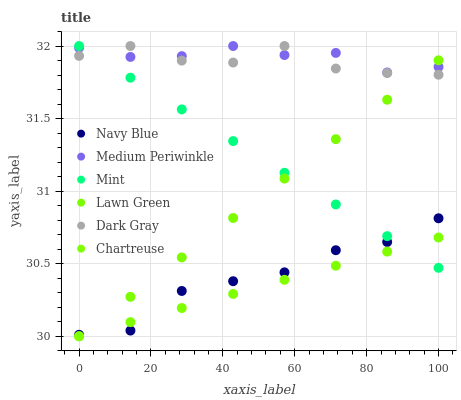Does Chartreuse have the minimum area under the curve?
Answer yes or no. Yes. Does Medium Periwinkle have the maximum area under the curve?
Answer yes or no. Yes. Does Navy Blue have the minimum area under the curve?
Answer yes or no. No. Does Navy Blue have the maximum area under the curve?
Answer yes or no. No. Is Mint the smoothest?
Answer yes or no. Yes. Is Dark Gray the roughest?
Answer yes or no. Yes. Is Navy Blue the smoothest?
Answer yes or no. No. Is Navy Blue the roughest?
Answer yes or no. No. Does Lawn Green have the lowest value?
Answer yes or no. Yes. Does Navy Blue have the lowest value?
Answer yes or no. No. Does Mint have the highest value?
Answer yes or no. Yes. Does Navy Blue have the highest value?
Answer yes or no. No. Is Navy Blue less than Medium Periwinkle?
Answer yes or no. Yes. Is Medium Periwinkle greater than Chartreuse?
Answer yes or no. Yes. Does Mint intersect Lawn Green?
Answer yes or no. Yes. Is Mint less than Lawn Green?
Answer yes or no. No. Is Mint greater than Lawn Green?
Answer yes or no. No. Does Navy Blue intersect Medium Periwinkle?
Answer yes or no. No. 